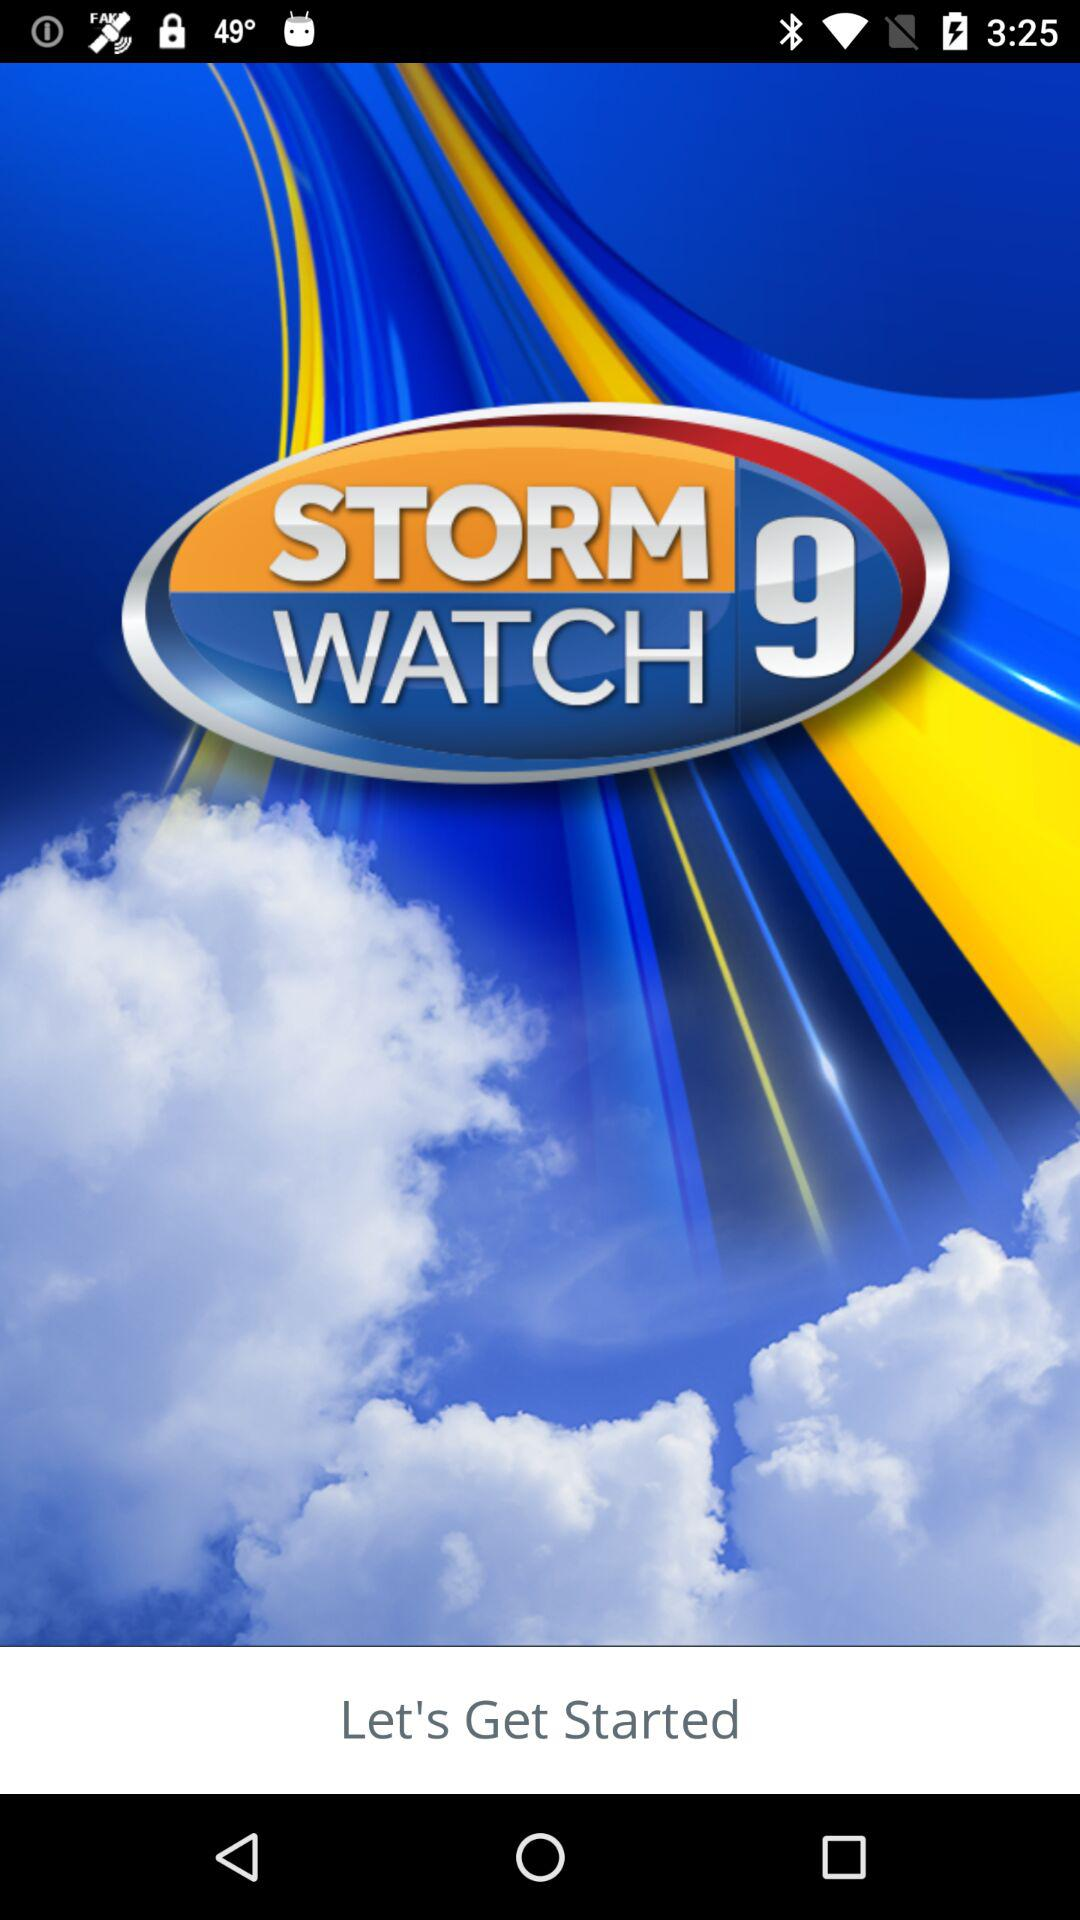What is the name of the application? The name of the application is "STORM WATCH 9". 